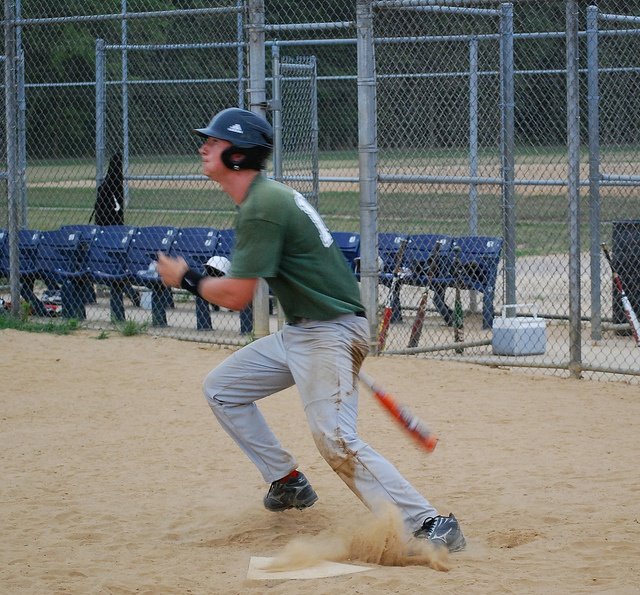Describe the objects in this image and their specific colors. I can see people in gray, darkgray, black, and teal tones, bench in gray, darkblue, and navy tones, bench in gray, darkblue, black, and navy tones, bench in gray, navy, darkblue, black, and blue tones, and baseball bat in gray, darkgray, and brown tones in this image. 